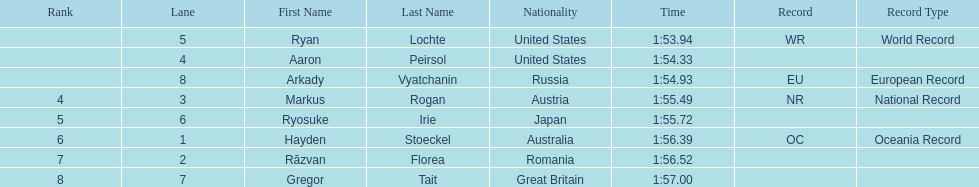Could you parse the entire table? {'header': ['Rank', 'Lane', 'First Name', 'Last Name', 'Nationality', 'Time', 'Record', 'Record Type'], 'rows': [['', '5', 'Ryan', 'Lochte', 'United States', '1:53.94', 'WR', 'World Record'], ['', '4', 'Aaron', 'Peirsol', 'United States', '1:54.33', '', ''], ['', '8', 'Arkady', 'Vyatchanin', 'Russia', '1:54.93', 'EU', 'European Record'], ['4', '3', 'Markus', 'Rogan', 'Austria', '1:55.49', 'NR', 'National Record'], ['5', '6', 'Ryosuke', 'Irie', 'Japan', '1:55.72', '', ''], ['6', '1', 'Hayden', 'Stoeckel', 'Australia', '1:56.39', 'OC', 'Oceania Record'], ['7', '2', 'Răzvan', 'Florea', 'Romania', '1:56.52', '', ''], ['8', '7', 'Gregor', 'Tait', 'Great Britain', '1:57.00', '', '']]} How many swimmers finished in less than 1:55? 3. 